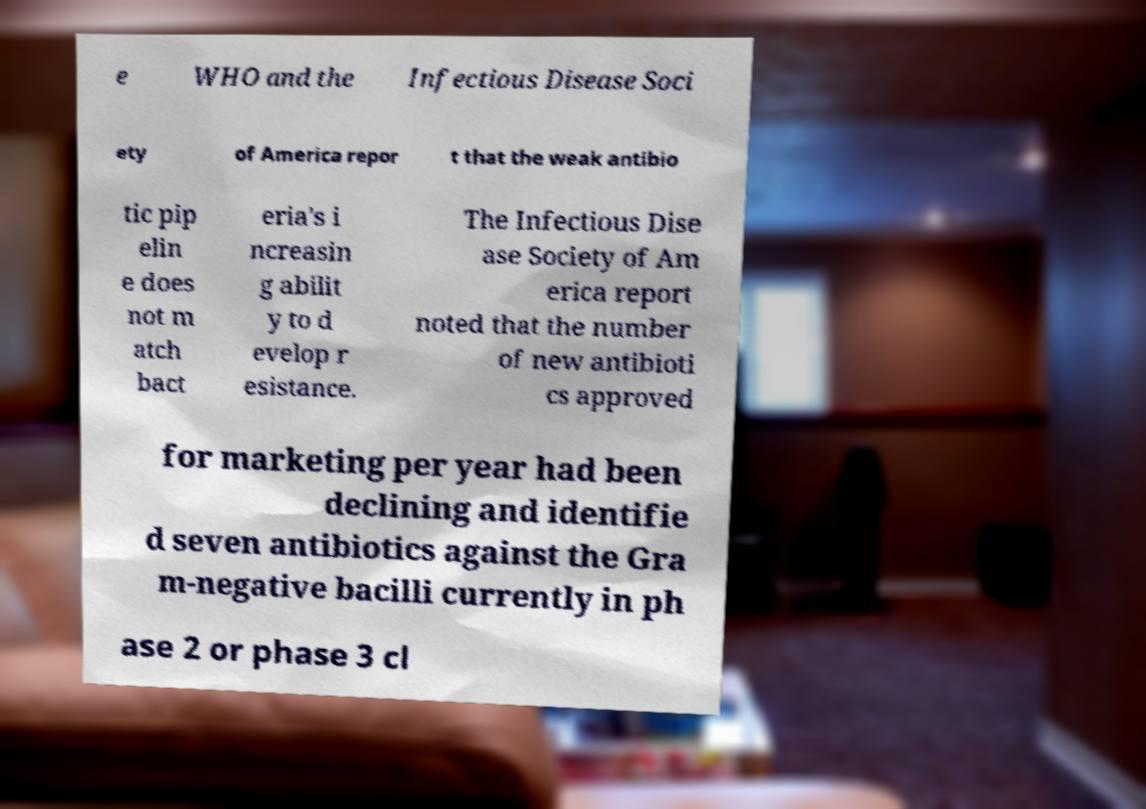Could you extract and type out the text from this image? e WHO and the Infectious Disease Soci ety of America repor t that the weak antibio tic pip elin e does not m atch bact eria's i ncreasin g abilit y to d evelop r esistance. The Infectious Dise ase Society of Am erica report noted that the number of new antibioti cs approved for marketing per year had been declining and identifie d seven antibiotics against the Gra m-negative bacilli currently in ph ase 2 or phase 3 cl 